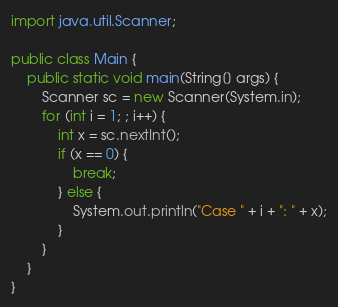<code> <loc_0><loc_0><loc_500><loc_500><_Java_>import java.util.Scanner;

public class Main {
    public static void main(String[] args) {
        Scanner sc = new Scanner(System.in);
        for (int i = 1; ; i++) {
            int x = sc.nextInt();
            if (x == 0) {
                break;
            } else {
                System.out.println("Case " + i + ": " + x);
            }
        }
    }
}
</code> 